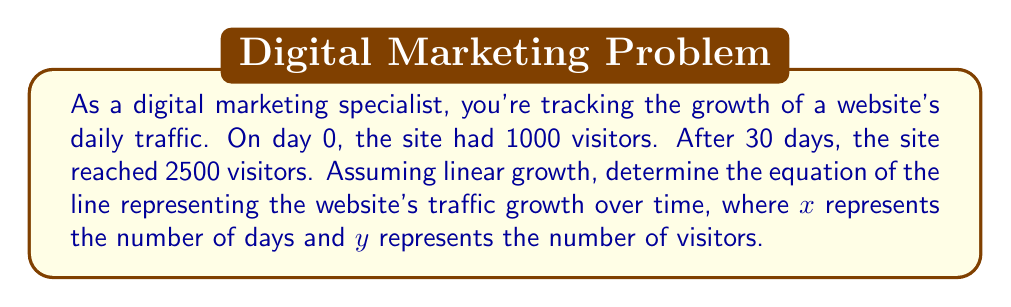Could you help me with this problem? To find the equation of the line, we'll use the point-slope form: $y - y_1 = m(x - x_1)$

1. First, let's identify two points on the line:
   $(x_1, y_1) = (0, 1000)$ and $(x_2, y_2) = (30, 2500)$

2. Calculate the slope (m) using the point-slope formula:
   $m = \frac{y_2 - y_1}{x_2 - x_1} = \frac{2500 - 1000}{30 - 0} = \frac{1500}{30} = 50$

3. Now we have the slope and a point $(0, 1000)$. Let's use the point-slope form:
   $y - 1000 = 50(x - 0)$

4. Simplify:
   $y - 1000 = 50x$

5. Rearrange to slope-intercept form $(y = mx + b)$:
   $y = 50x + 1000$

This equation represents the line of website traffic growth over time, where $x$ is the number of days and $y$ is the number of visitors.
Answer: $y = 50x + 1000$ 